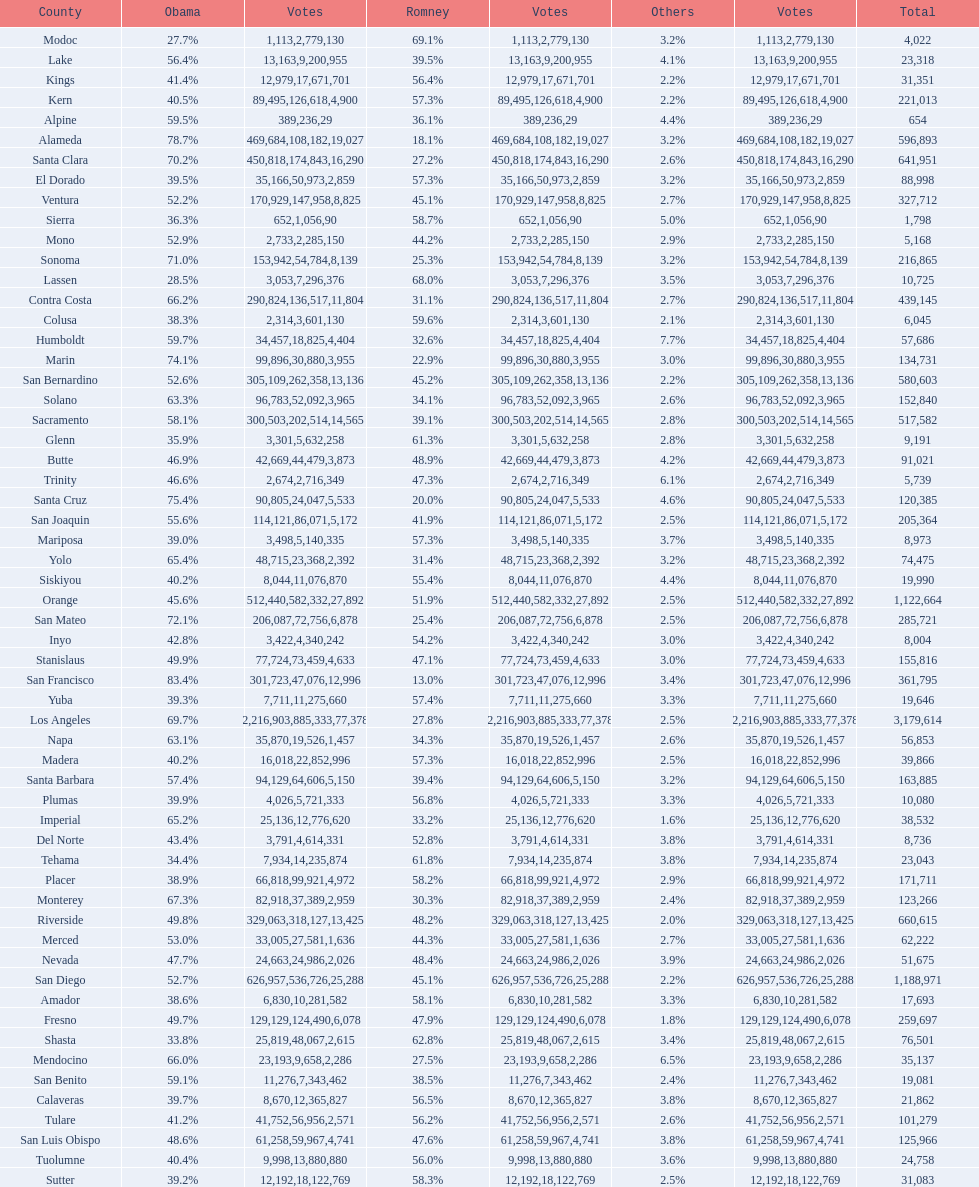What number of counties gave obama 75% or more of the votes? 3. 